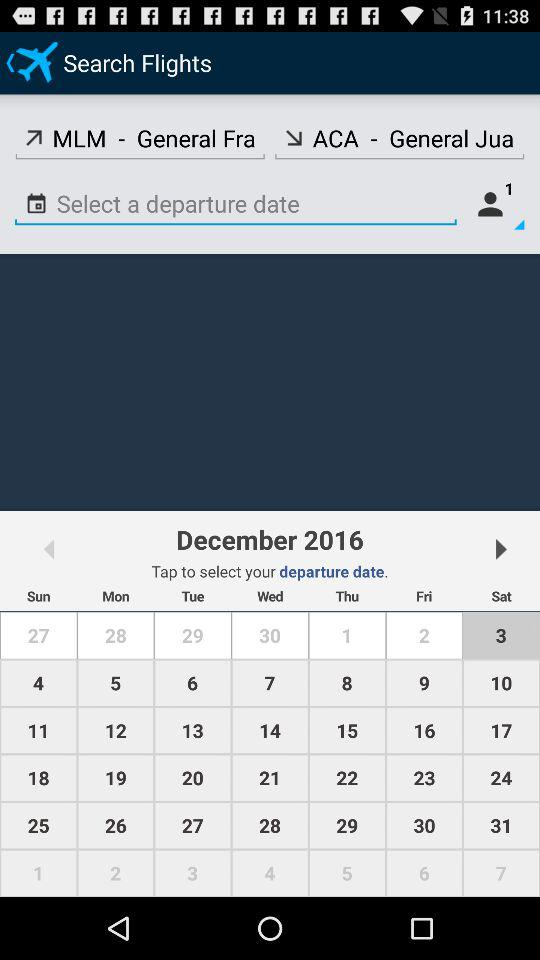What's the departure place? The departure place is "MLM - General Fra". 